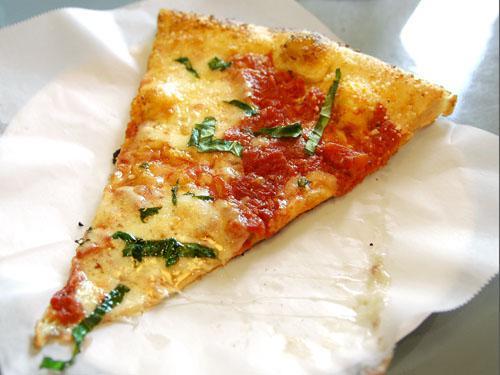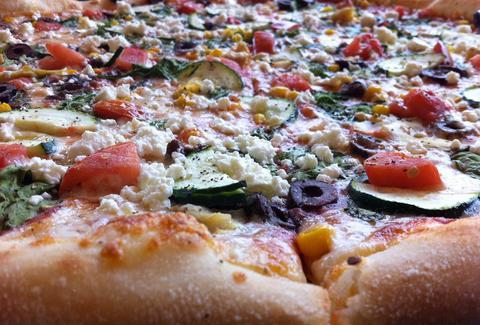The first image is the image on the left, the second image is the image on the right. For the images shown, is this caption "The right image contains a sliced round pizza with no slices missing, and the left image contains at least one wedge-shaped slice of pizza on white paper." true? Answer yes or no. Yes. The first image is the image on the left, the second image is the image on the right. Given the left and right images, does the statement "The left image shows at least one single slice of pizza." hold true? Answer yes or no. Yes. 